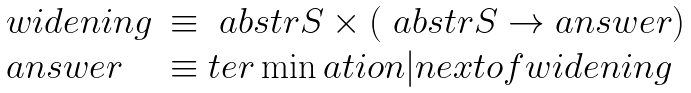<formula> <loc_0><loc_0><loc_500><loc_500>\begin{array} { l l } w i d e n i n g & \equiv \ a b s t r { S } \times ( \ a b s t r { S } \rightarrow a n s w e r ) \\ a n s w e r & \equiv t e r \min a t i o n | n e x t o f w i d e n i n g \\ \end{array}</formula> 